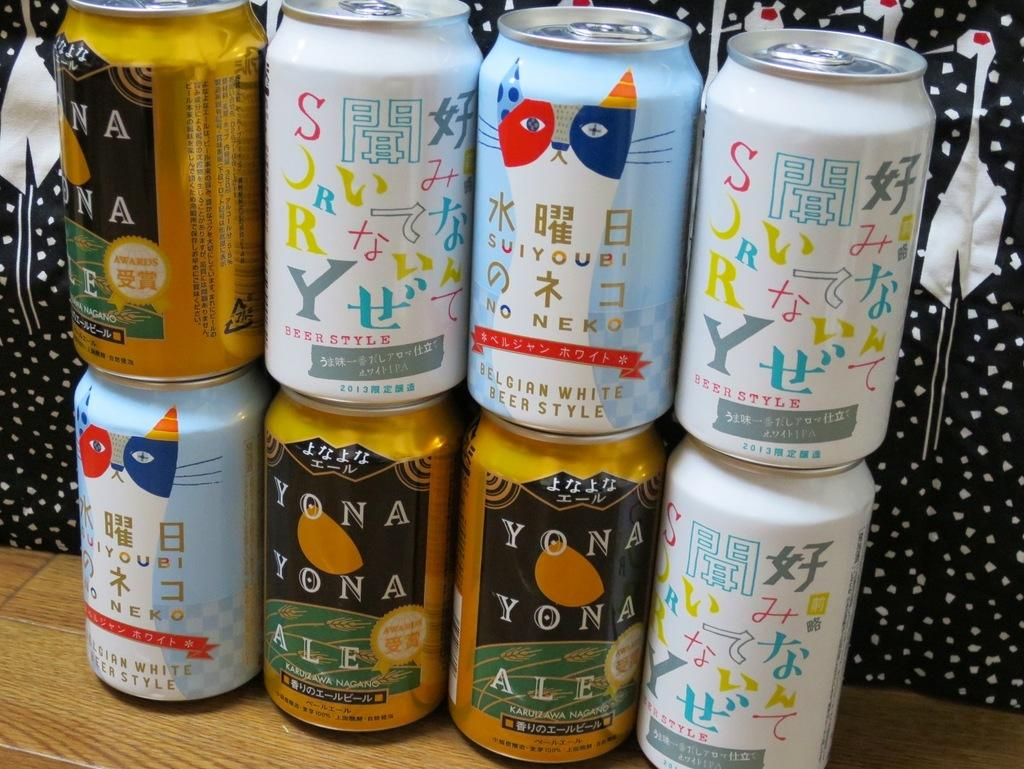<image>
Describe the image concisely. A stack of eight beer cans that say Yona Yona Ale. 